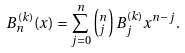<formula> <loc_0><loc_0><loc_500><loc_500>B _ { n } ^ { ( k ) } ( x ) = \sum _ { j = 0 } ^ { n } \left ( ^ { n } _ { j } \right ) B _ { j } ^ { ( k ) } x ^ { n - j } .</formula> 